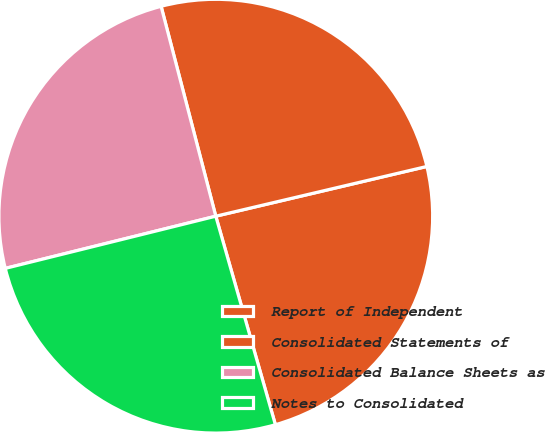Convert chart. <chart><loc_0><loc_0><loc_500><loc_500><pie_chart><fcel>Report of Independent<fcel>Consolidated Statements of<fcel>Consolidated Balance Sheets as<fcel>Notes to Consolidated<nl><fcel>24.25%<fcel>25.37%<fcel>24.81%<fcel>25.56%<nl></chart> 